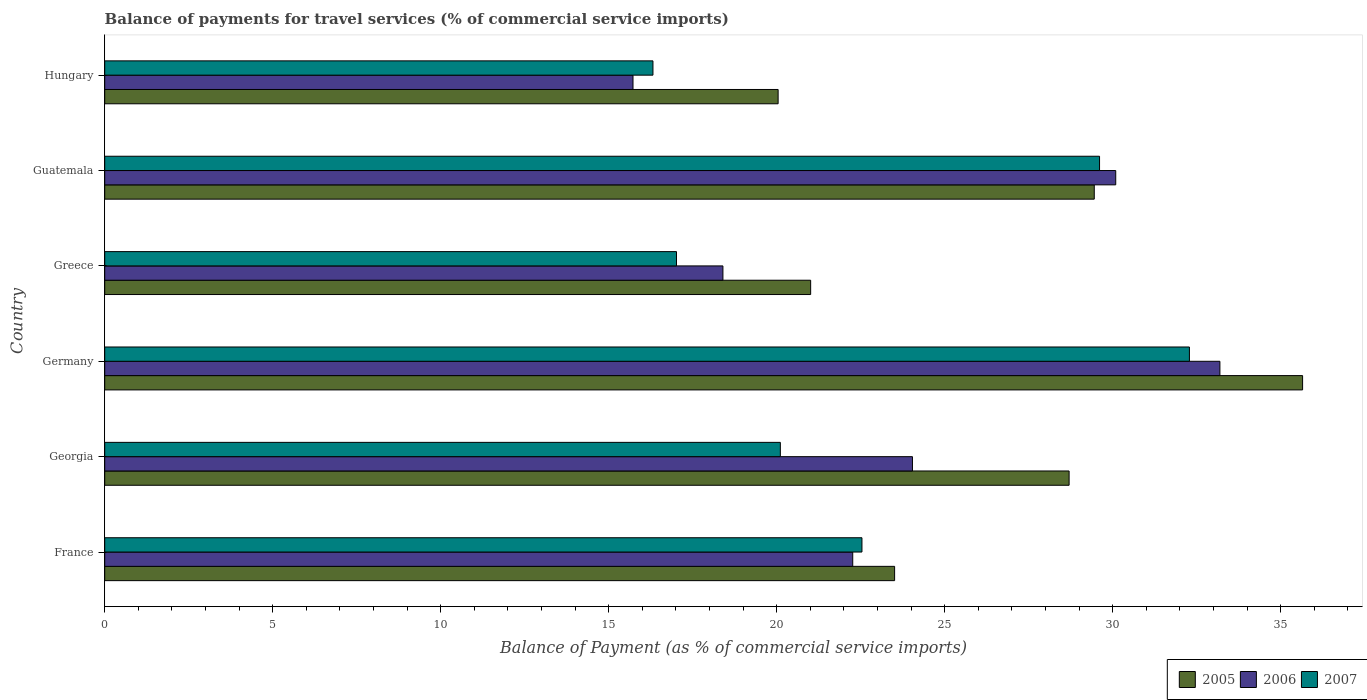How many different coloured bars are there?
Your answer should be very brief. 3. In how many cases, is the number of bars for a given country not equal to the number of legend labels?
Your response must be concise. 0. What is the balance of payments for travel services in 2005 in Germany?
Give a very brief answer. 35.65. Across all countries, what is the maximum balance of payments for travel services in 2007?
Your answer should be very brief. 32.28. Across all countries, what is the minimum balance of payments for travel services in 2007?
Offer a terse response. 16.32. In which country was the balance of payments for travel services in 2005 maximum?
Make the answer very short. Germany. In which country was the balance of payments for travel services in 2006 minimum?
Ensure brevity in your answer.  Hungary. What is the total balance of payments for travel services in 2006 in the graph?
Offer a terse response. 143.71. What is the difference between the balance of payments for travel services in 2005 in Georgia and that in Guatemala?
Keep it short and to the point. -0.75. What is the difference between the balance of payments for travel services in 2005 in Guatemala and the balance of payments for travel services in 2006 in Hungary?
Offer a terse response. 13.73. What is the average balance of payments for travel services in 2006 per country?
Make the answer very short. 23.95. What is the difference between the balance of payments for travel services in 2005 and balance of payments for travel services in 2006 in Germany?
Provide a succinct answer. 2.46. In how many countries, is the balance of payments for travel services in 2006 greater than 2 %?
Provide a succinct answer. 6. What is the ratio of the balance of payments for travel services in 2005 in France to that in Georgia?
Your answer should be compact. 0.82. Is the balance of payments for travel services in 2006 in France less than that in Hungary?
Your answer should be very brief. No. Is the difference between the balance of payments for travel services in 2005 in Greece and Hungary greater than the difference between the balance of payments for travel services in 2006 in Greece and Hungary?
Ensure brevity in your answer.  No. What is the difference between the highest and the second highest balance of payments for travel services in 2007?
Provide a short and direct response. 2.67. What is the difference between the highest and the lowest balance of payments for travel services in 2007?
Offer a very short reply. 15.97. Is the sum of the balance of payments for travel services in 2006 in France and Greece greater than the maximum balance of payments for travel services in 2005 across all countries?
Make the answer very short. Yes. What does the 2nd bar from the top in Georgia represents?
Your answer should be compact. 2006. What does the 2nd bar from the bottom in Georgia represents?
Your answer should be very brief. 2006. Is it the case that in every country, the sum of the balance of payments for travel services in 2007 and balance of payments for travel services in 2006 is greater than the balance of payments for travel services in 2005?
Make the answer very short. Yes. Are all the bars in the graph horizontal?
Provide a short and direct response. Yes. What is the difference between two consecutive major ticks on the X-axis?
Provide a succinct answer. 5. Does the graph contain any zero values?
Your response must be concise. No. Where does the legend appear in the graph?
Keep it short and to the point. Bottom right. How many legend labels are there?
Offer a very short reply. 3. How are the legend labels stacked?
Provide a short and direct response. Horizontal. What is the title of the graph?
Offer a terse response. Balance of payments for travel services (% of commercial service imports). Does "2013" appear as one of the legend labels in the graph?
Offer a terse response. No. What is the label or title of the X-axis?
Provide a short and direct response. Balance of Payment (as % of commercial service imports). What is the label or title of the Y-axis?
Offer a terse response. Country. What is the Balance of Payment (as % of commercial service imports) in 2005 in France?
Ensure brevity in your answer.  23.51. What is the Balance of Payment (as % of commercial service imports) in 2006 in France?
Your answer should be very brief. 22.26. What is the Balance of Payment (as % of commercial service imports) of 2007 in France?
Offer a terse response. 22.54. What is the Balance of Payment (as % of commercial service imports) of 2005 in Georgia?
Make the answer very short. 28.7. What is the Balance of Payment (as % of commercial service imports) in 2006 in Georgia?
Provide a short and direct response. 24.04. What is the Balance of Payment (as % of commercial service imports) of 2007 in Georgia?
Offer a very short reply. 20.11. What is the Balance of Payment (as % of commercial service imports) in 2005 in Germany?
Keep it short and to the point. 35.65. What is the Balance of Payment (as % of commercial service imports) in 2006 in Germany?
Offer a very short reply. 33.19. What is the Balance of Payment (as % of commercial service imports) in 2007 in Germany?
Your answer should be very brief. 32.28. What is the Balance of Payment (as % of commercial service imports) of 2005 in Greece?
Your answer should be very brief. 21.01. What is the Balance of Payment (as % of commercial service imports) in 2006 in Greece?
Give a very brief answer. 18.4. What is the Balance of Payment (as % of commercial service imports) of 2007 in Greece?
Your answer should be compact. 17.02. What is the Balance of Payment (as % of commercial service imports) of 2005 in Guatemala?
Your answer should be compact. 29.45. What is the Balance of Payment (as % of commercial service imports) of 2006 in Guatemala?
Make the answer very short. 30.09. What is the Balance of Payment (as % of commercial service imports) of 2007 in Guatemala?
Ensure brevity in your answer.  29.61. What is the Balance of Payment (as % of commercial service imports) of 2005 in Hungary?
Make the answer very short. 20.04. What is the Balance of Payment (as % of commercial service imports) of 2006 in Hungary?
Ensure brevity in your answer.  15.72. What is the Balance of Payment (as % of commercial service imports) in 2007 in Hungary?
Keep it short and to the point. 16.32. Across all countries, what is the maximum Balance of Payment (as % of commercial service imports) in 2005?
Keep it short and to the point. 35.65. Across all countries, what is the maximum Balance of Payment (as % of commercial service imports) of 2006?
Give a very brief answer. 33.19. Across all countries, what is the maximum Balance of Payment (as % of commercial service imports) in 2007?
Your answer should be compact. 32.28. Across all countries, what is the minimum Balance of Payment (as % of commercial service imports) in 2005?
Provide a short and direct response. 20.04. Across all countries, what is the minimum Balance of Payment (as % of commercial service imports) of 2006?
Give a very brief answer. 15.72. Across all countries, what is the minimum Balance of Payment (as % of commercial service imports) in 2007?
Your answer should be compact. 16.32. What is the total Balance of Payment (as % of commercial service imports) of 2005 in the graph?
Make the answer very short. 158.37. What is the total Balance of Payment (as % of commercial service imports) in 2006 in the graph?
Ensure brevity in your answer.  143.71. What is the total Balance of Payment (as % of commercial service imports) of 2007 in the graph?
Offer a very short reply. 137.87. What is the difference between the Balance of Payment (as % of commercial service imports) of 2005 in France and that in Georgia?
Offer a terse response. -5.19. What is the difference between the Balance of Payment (as % of commercial service imports) of 2006 in France and that in Georgia?
Give a very brief answer. -1.78. What is the difference between the Balance of Payment (as % of commercial service imports) of 2007 in France and that in Georgia?
Give a very brief answer. 2.43. What is the difference between the Balance of Payment (as % of commercial service imports) in 2005 in France and that in Germany?
Keep it short and to the point. -12.14. What is the difference between the Balance of Payment (as % of commercial service imports) in 2006 in France and that in Germany?
Your response must be concise. -10.93. What is the difference between the Balance of Payment (as % of commercial service imports) of 2007 in France and that in Germany?
Give a very brief answer. -9.75. What is the difference between the Balance of Payment (as % of commercial service imports) of 2005 in France and that in Greece?
Ensure brevity in your answer.  2.5. What is the difference between the Balance of Payment (as % of commercial service imports) of 2006 in France and that in Greece?
Your answer should be very brief. 3.86. What is the difference between the Balance of Payment (as % of commercial service imports) in 2007 in France and that in Greece?
Offer a terse response. 5.52. What is the difference between the Balance of Payment (as % of commercial service imports) of 2005 in France and that in Guatemala?
Provide a succinct answer. -5.94. What is the difference between the Balance of Payment (as % of commercial service imports) in 2006 in France and that in Guatemala?
Provide a short and direct response. -7.83. What is the difference between the Balance of Payment (as % of commercial service imports) of 2007 in France and that in Guatemala?
Make the answer very short. -7.07. What is the difference between the Balance of Payment (as % of commercial service imports) in 2005 in France and that in Hungary?
Your answer should be compact. 3.47. What is the difference between the Balance of Payment (as % of commercial service imports) in 2006 in France and that in Hungary?
Give a very brief answer. 6.54. What is the difference between the Balance of Payment (as % of commercial service imports) in 2007 in France and that in Hungary?
Your response must be concise. 6.22. What is the difference between the Balance of Payment (as % of commercial service imports) of 2005 in Georgia and that in Germany?
Ensure brevity in your answer.  -6.95. What is the difference between the Balance of Payment (as % of commercial service imports) in 2006 in Georgia and that in Germany?
Give a very brief answer. -9.15. What is the difference between the Balance of Payment (as % of commercial service imports) in 2007 in Georgia and that in Germany?
Offer a terse response. -12.18. What is the difference between the Balance of Payment (as % of commercial service imports) in 2005 in Georgia and that in Greece?
Your response must be concise. 7.69. What is the difference between the Balance of Payment (as % of commercial service imports) of 2006 in Georgia and that in Greece?
Offer a very short reply. 5.64. What is the difference between the Balance of Payment (as % of commercial service imports) of 2007 in Georgia and that in Greece?
Give a very brief answer. 3.09. What is the difference between the Balance of Payment (as % of commercial service imports) in 2005 in Georgia and that in Guatemala?
Provide a succinct answer. -0.75. What is the difference between the Balance of Payment (as % of commercial service imports) in 2006 in Georgia and that in Guatemala?
Your answer should be very brief. -6.05. What is the difference between the Balance of Payment (as % of commercial service imports) in 2007 in Georgia and that in Guatemala?
Give a very brief answer. -9.5. What is the difference between the Balance of Payment (as % of commercial service imports) of 2005 in Georgia and that in Hungary?
Make the answer very short. 8.66. What is the difference between the Balance of Payment (as % of commercial service imports) of 2006 in Georgia and that in Hungary?
Offer a very short reply. 8.32. What is the difference between the Balance of Payment (as % of commercial service imports) of 2007 in Georgia and that in Hungary?
Offer a terse response. 3.79. What is the difference between the Balance of Payment (as % of commercial service imports) of 2005 in Germany and that in Greece?
Your response must be concise. 14.64. What is the difference between the Balance of Payment (as % of commercial service imports) of 2006 in Germany and that in Greece?
Your response must be concise. 14.79. What is the difference between the Balance of Payment (as % of commercial service imports) in 2007 in Germany and that in Greece?
Your answer should be very brief. 15.27. What is the difference between the Balance of Payment (as % of commercial service imports) in 2005 in Germany and that in Guatemala?
Your answer should be very brief. 6.2. What is the difference between the Balance of Payment (as % of commercial service imports) of 2006 in Germany and that in Guatemala?
Offer a very short reply. 3.1. What is the difference between the Balance of Payment (as % of commercial service imports) in 2007 in Germany and that in Guatemala?
Your answer should be compact. 2.67. What is the difference between the Balance of Payment (as % of commercial service imports) of 2005 in Germany and that in Hungary?
Provide a short and direct response. 15.61. What is the difference between the Balance of Payment (as % of commercial service imports) of 2006 in Germany and that in Hungary?
Keep it short and to the point. 17.47. What is the difference between the Balance of Payment (as % of commercial service imports) of 2007 in Germany and that in Hungary?
Make the answer very short. 15.97. What is the difference between the Balance of Payment (as % of commercial service imports) in 2005 in Greece and that in Guatemala?
Your answer should be compact. -8.44. What is the difference between the Balance of Payment (as % of commercial service imports) in 2006 in Greece and that in Guatemala?
Offer a terse response. -11.69. What is the difference between the Balance of Payment (as % of commercial service imports) in 2007 in Greece and that in Guatemala?
Provide a short and direct response. -12.59. What is the difference between the Balance of Payment (as % of commercial service imports) in 2005 in Greece and that in Hungary?
Make the answer very short. 0.97. What is the difference between the Balance of Payment (as % of commercial service imports) of 2006 in Greece and that in Hungary?
Ensure brevity in your answer.  2.68. What is the difference between the Balance of Payment (as % of commercial service imports) in 2007 in Greece and that in Hungary?
Provide a short and direct response. 0.7. What is the difference between the Balance of Payment (as % of commercial service imports) of 2005 in Guatemala and that in Hungary?
Your response must be concise. 9.41. What is the difference between the Balance of Payment (as % of commercial service imports) in 2006 in Guatemala and that in Hungary?
Provide a succinct answer. 14.37. What is the difference between the Balance of Payment (as % of commercial service imports) in 2007 in Guatemala and that in Hungary?
Provide a succinct answer. 13.29. What is the difference between the Balance of Payment (as % of commercial service imports) of 2005 in France and the Balance of Payment (as % of commercial service imports) of 2006 in Georgia?
Ensure brevity in your answer.  -0.53. What is the difference between the Balance of Payment (as % of commercial service imports) of 2005 in France and the Balance of Payment (as % of commercial service imports) of 2007 in Georgia?
Provide a succinct answer. 3.4. What is the difference between the Balance of Payment (as % of commercial service imports) of 2006 in France and the Balance of Payment (as % of commercial service imports) of 2007 in Georgia?
Offer a very short reply. 2.15. What is the difference between the Balance of Payment (as % of commercial service imports) of 2005 in France and the Balance of Payment (as % of commercial service imports) of 2006 in Germany?
Your answer should be compact. -9.68. What is the difference between the Balance of Payment (as % of commercial service imports) in 2005 in France and the Balance of Payment (as % of commercial service imports) in 2007 in Germany?
Give a very brief answer. -8.77. What is the difference between the Balance of Payment (as % of commercial service imports) in 2006 in France and the Balance of Payment (as % of commercial service imports) in 2007 in Germany?
Give a very brief answer. -10.02. What is the difference between the Balance of Payment (as % of commercial service imports) in 2005 in France and the Balance of Payment (as % of commercial service imports) in 2006 in Greece?
Offer a very short reply. 5.11. What is the difference between the Balance of Payment (as % of commercial service imports) of 2005 in France and the Balance of Payment (as % of commercial service imports) of 2007 in Greece?
Give a very brief answer. 6.49. What is the difference between the Balance of Payment (as % of commercial service imports) of 2006 in France and the Balance of Payment (as % of commercial service imports) of 2007 in Greece?
Your answer should be compact. 5.25. What is the difference between the Balance of Payment (as % of commercial service imports) in 2005 in France and the Balance of Payment (as % of commercial service imports) in 2006 in Guatemala?
Offer a terse response. -6.58. What is the difference between the Balance of Payment (as % of commercial service imports) of 2005 in France and the Balance of Payment (as % of commercial service imports) of 2007 in Guatemala?
Ensure brevity in your answer.  -6.1. What is the difference between the Balance of Payment (as % of commercial service imports) in 2006 in France and the Balance of Payment (as % of commercial service imports) in 2007 in Guatemala?
Give a very brief answer. -7.35. What is the difference between the Balance of Payment (as % of commercial service imports) of 2005 in France and the Balance of Payment (as % of commercial service imports) of 2006 in Hungary?
Provide a succinct answer. 7.79. What is the difference between the Balance of Payment (as % of commercial service imports) of 2005 in France and the Balance of Payment (as % of commercial service imports) of 2007 in Hungary?
Offer a very short reply. 7.19. What is the difference between the Balance of Payment (as % of commercial service imports) in 2006 in France and the Balance of Payment (as % of commercial service imports) in 2007 in Hungary?
Keep it short and to the point. 5.95. What is the difference between the Balance of Payment (as % of commercial service imports) in 2005 in Georgia and the Balance of Payment (as % of commercial service imports) in 2006 in Germany?
Keep it short and to the point. -4.49. What is the difference between the Balance of Payment (as % of commercial service imports) of 2005 in Georgia and the Balance of Payment (as % of commercial service imports) of 2007 in Germany?
Ensure brevity in your answer.  -3.58. What is the difference between the Balance of Payment (as % of commercial service imports) in 2006 in Georgia and the Balance of Payment (as % of commercial service imports) in 2007 in Germany?
Your answer should be very brief. -8.24. What is the difference between the Balance of Payment (as % of commercial service imports) in 2005 in Georgia and the Balance of Payment (as % of commercial service imports) in 2006 in Greece?
Keep it short and to the point. 10.3. What is the difference between the Balance of Payment (as % of commercial service imports) of 2005 in Georgia and the Balance of Payment (as % of commercial service imports) of 2007 in Greece?
Provide a short and direct response. 11.69. What is the difference between the Balance of Payment (as % of commercial service imports) in 2006 in Georgia and the Balance of Payment (as % of commercial service imports) in 2007 in Greece?
Your answer should be very brief. 7.02. What is the difference between the Balance of Payment (as % of commercial service imports) of 2005 in Georgia and the Balance of Payment (as % of commercial service imports) of 2006 in Guatemala?
Keep it short and to the point. -1.39. What is the difference between the Balance of Payment (as % of commercial service imports) in 2005 in Georgia and the Balance of Payment (as % of commercial service imports) in 2007 in Guatemala?
Your answer should be very brief. -0.91. What is the difference between the Balance of Payment (as % of commercial service imports) in 2006 in Georgia and the Balance of Payment (as % of commercial service imports) in 2007 in Guatemala?
Keep it short and to the point. -5.57. What is the difference between the Balance of Payment (as % of commercial service imports) in 2005 in Georgia and the Balance of Payment (as % of commercial service imports) in 2006 in Hungary?
Offer a terse response. 12.98. What is the difference between the Balance of Payment (as % of commercial service imports) of 2005 in Georgia and the Balance of Payment (as % of commercial service imports) of 2007 in Hungary?
Keep it short and to the point. 12.39. What is the difference between the Balance of Payment (as % of commercial service imports) of 2006 in Georgia and the Balance of Payment (as % of commercial service imports) of 2007 in Hungary?
Give a very brief answer. 7.72. What is the difference between the Balance of Payment (as % of commercial service imports) in 2005 in Germany and the Balance of Payment (as % of commercial service imports) in 2006 in Greece?
Your answer should be compact. 17.25. What is the difference between the Balance of Payment (as % of commercial service imports) in 2005 in Germany and the Balance of Payment (as % of commercial service imports) in 2007 in Greece?
Your answer should be compact. 18.63. What is the difference between the Balance of Payment (as % of commercial service imports) of 2006 in Germany and the Balance of Payment (as % of commercial service imports) of 2007 in Greece?
Offer a very short reply. 16.17. What is the difference between the Balance of Payment (as % of commercial service imports) in 2005 in Germany and the Balance of Payment (as % of commercial service imports) in 2006 in Guatemala?
Your answer should be very brief. 5.56. What is the difference between the Balance of Payment (as % of commercial service imports) in 2005 in Germany and the Balance of Payment (as % of commercial service imports) in 2007 in Guatemala?
Your answer should be very brief. 6.04. What is the difference between the Balance of Payment (as % of commercial service imports) in 2006 in Germany and the Balance of Payment (as % of commercial service imports) in 2007 in Guatemala?
Provide a succinct answer. 3.58. What is the difference between the Balance of Payment (as % of commercial service imports) in 2005 in Germany and the Balance of Payment (as % of commercial service imports) in 2006 in Hungary?
Make the answer very short. 19.93. What is the difference between the Balance of Payment (as % of commercial service imports) of 2005 in Germany and the Balance of Payment (as % of commercial service imports) of 2007 in Hungary?
Your response must be concise. 19.34. What is the difference between the Balance of Payment (as % of commercial service imports) in 2006 in Germany and the Balance of Payment (as % of commercial service imports) in 2007 in Hungary?
Offer a terse response. 16.87. What is the difference between the Balance of Payment (as % of commercial service imports) in 2005 in Greece and the Balance of Payment (as % of commercial service imports) in 2006 in Guatemala?
Your answer should be very brief. -9.08. What is the difference between the Balance of Payment (as % of commercial service imports) in 2005 in Greece and the Balance of Payment (as % of commercial service imports) in 2007 in Guatemala?
Ensure brevity in your answer.  -8.6. What is the difference between the Balance of Payment (as % of commercial service imports) of 2006 in Greece and the Balance of Payment (as % of commercial service imports) of 2007 in Guatemala?
Keep it short and to the point. -11.21. What is the difference between the Balance of Payment (as % of commercial service imports) of 2005 in Greece and the Balance of Payment (as % of commercial service imports) of 2006 in Hungary?
Offer a terse response. 5.29. What is the difference between the Balance of Payment (as % of commercial service imports) in 2005 in Greece and the Balance of Payment (as % of commercial service imports) in 2007 in Hungary?
Provide a succinct answer. 4.69. What is the difference between the Balance of Payment (as % of commercial service imports) in 2006 in Greece and the Balance of Payment (as % of commercial service imports) in 2007 in Hungary?
Your answer should be very brief. 2.08. What is the difference between the Balance of Payment (as % of commercial service imports) of 2005 in Guatemala and the Balance of Payment (as % of commercial service imports) of 2006 in Hungary?
Provide a succinct answer. 13.73. What is the difference between the Balance of Payment (as % of commercial service imports) of 2005 in Guatemala and the Balance of Payment (as % of commercial service imports) of 2007 in Hungary?
Give a very brief answer. 13.13. What is the difference between the Balance of Payment (as % of commercial service imports) in 2006 in Guatemala and the Balance of Payment (as % of commercial service imports) in 2007 in Hungary?
Your answer should be compact. 13.77. What is the average Balance of Payment (as % of commercial service imports) of 2005 per country?
Give a very brief answer. 26.39. What is the average Balance of Payment (as % of commercial service imports) in 2006 per country?
Your answer should be compact. 23.95. What is the average Balance of Payment (as % of commercial service imports) in 2007 per country?
Give a very brief answer. 22.98. What is the difference between the Balance of Payment (as % of commercial service imports) of 2005 and Balance of Payment (as % of commercial service imports) of 2006 in France?
Ensure brevity in your answer.  1.25. What is the difference between the Balance of Payment (as % of commercial service imports) in 2005 and Balance of Payment (as % of commercial service imports) in 2007 in France?
Your answer should be compact. 0.97. What is the difference between the Balance of Payment (as % of commercial service imports) of 2006 and Balance of Payment (as % of commercial service imports) of 2007 in France?
Provide a short and direct response. -0.27. What is the difference between the Balance of Payment (as % of commercial service imports) in 2005 and Balance of Payment (as % of commercial service imports) in 2006 in Georgia?
Keep it short and to the point. 4.66. What is the difference between the Balance of Payment (as % of commercial service imports) of 2005 and Balance of Payment (as % of commercial service imports) of 2007 in Georgia?
Offer a very short reply. 8.59. What is the difference between the Balance of Payment (as % of commercial service imports) of 2006 and Balance of Payment (as % of commercial service imports) of 2007 in Georgia?
Give a very brief answer. 3.93. What is the difference between the Balance of Payment (as % of commercial service imports) in 2005 and Balance of Payment (as % of commercial service imports) in 2006 in Germany?
Your response must be concise. 2.46. What is the difference between the Balance of Payment (as % of commercial service imports) in 2005 and Balance of Payment (as % of commercial service imports) in 2007 in Germany?
Keep it short and to the point. 3.37. What is the difference between the Balance of Payment (as % of commercial service imports) of 2006 and Balance of Payment (as % of commercial service imports) of 2007 in Germany?
Your response must be concise. 0.91. What is the difference between the Balance of Payment (as % of commercial service imports) of 2005 and Balance of Payment (as % of commercial service imports) of 2006 in Greece?
Provide a short and direct response. 2.61. What is the difference between the Balance of Payment (as % of commercial service imports) in 2005 and Balance of Payment (as % of commercial service imports) in 2007 in Greece?
Provide a short and direct response. 3.99. What is the difference between the Balance of Payment (as % of commercial service imports) in 2006 and Balance of Payment (as % of commercial service imports) in 2007 in Greece?
Ensure brevity in your answer.  1.38. What is the difference between the Balance of Payment (as % of commercial service imports) of 2005 and Balance of Payment (as % of commercial service imports) of 2006 in Guatemala?
Offer a terse response. -0.64. What is the difference between the Balance of Payment (as % of commercial service imports) of 2005 and Balance of Payment (as % of commercial service imports) of 2007 in Guatemala?
Ensure brevity in your answer.  -0.16. What is the difference between the Balance of Payment (as % of commercial service imports) in 2006 and Balance of Payment (as % of commercial service imports) in 2007 in Guatemala?
Provide a succinct answer. 0.48. What is the difference between the Balance of Payment (as % of commercial service imports) of 2005 and Balance of Payment (as % of commercial service imports) of 2006 in Hungary?
Offer a terse response. 4.32. What is the difference between the Balance of Payment (as % of commercial service imports) in 2005 and Balance of Payment (as % of commercial service imports) in 2007 in Hungary?
Provide a succinct answer. 3.73. What is the difference between the Balance of Payment (as % of commercial service imports) of 2006 and Balance of Payment (as % of commercial service imports) of 2007 in Hungary?
Give a very brief answer. -0.59. What is the ratio of the Balance of Payment (as % of commercial service imports) of 2005 in France to that in Georgia?
Your response must be concise. 0.82. What is the ratio of the Balance of Payment (as % of commercial service imports) in 2006 in France to that in Georgia?
Offer a very short reply. 0.93. What is the ratio of the Balance of Payment (as % of commercial service imports) of 2007 in France to that in Georgia?
Your answer should be compact. 1.12. What is the ratio of the Balance of Payment (as % of commercial service imports) in 2005 in France to that in Germany?
Provide a short and direct response. 0.66. What is the ratio of the Balance of Payment (as % of commercial service imports) of 2006 in France to that in Germany?
Provide a short and direct response. 0.67. What is the ratio of the Balance of Payment (as % of commercial service imports) in 2007 in France to that in Germany?
Make the answer very short. 0.7. What is the ratio of the Balance of Payment (as % of commercial service imports) in 2005 in France to that in Greece?
Ensure brevity in your answer.  1.12. What is the ratio of the Balance of Payment (as % of commercial service imports) in 2006 in France to that in Greece?
Your answer should be very brief. 1.21. What is the ratio of the Balance of Payment (as % of commercial service imports) of 2007 in France to that in Greece?
Make the answer very short. 1.32. What is the ratio of the Balance of Payment (as % of commercial service imports) of 2005 in France to that in Guatemala?
Make the answer very short. 0.8. What is the ratio of the Balance of Payment (as % of commercial service imports) in 2006 in France to that in Guatemala?
Ensure brevity in your answer.  0.74. What is the ratio of the Balance of Payment (as % of commercial service imports) in 2007 in France to that in Guatemala?
Ensure brevity in your answer.  0.76. What is the ratio of the Balance of Payment (as % of commercial service imports) of 2005 in France to that in Hungary?
Offer a very short reply. 1.17. What is the ratio of the Balance of Payment (as % of commercial service imports) of 2006 in France to that in Hungary?
Offer a very short reply. 1.42. What is the ratio of the Balance of Payment (as % of commercial service imports) in 2007 in France to that in Hungary?
Give a very brief answer. 1.38. What is the ratio of the Balance of Payment (as % of commercial service imports) in 2005 in Georgia to that in Germany?
Give a very brief answer. 0.81. What is the ratio of the Balance of Payment (as % of commercial service imports) in 2006 in Georgia to that in Germany?
Offer a very short reply. 0.72. What is the ratio of the Balance of Payment (as % of commercial service imports) of 2007 in Georgia to that in Germany?
Your answer should be very brief. 0.62. What is the ratio of the Balance of Payment (as % of commercial service imports) of 2005 in Georgia to that in Greece?
Your answer should be compact. 1.37. What is the ratio of the Balance of Payment (as % of commercial service imports) in 2006 in Georgia to that in Greece?
Your answer should be very brief. 1.31. What is the ratio of the Balance of Payment (as % of commercial service imports) in 2007 in Georgia to that in Greece?
Make the answer very short. 1.18. What is the ratio of the Balance of Payment (as % of commercial service imports) in 2005 in Georgia to that in Guatemala?
Offer a terse response. 0.97. What is the ratio of the Balance of Payment (as % of commercial service imports) in 2006 in Georgia to that in Guatemala?
Provide a succinct answer. 0.8. What is the ratio of the Balance of Payment (as % of commercial service imports) of 2007 in Georgia to that in Guatemala?
Offer a very short reply. 0.68. What is the ratio of the Balance of Payment (as % of commercial service imports) in 2005 in Georgia to that in Hungary?
Your answer should be very brief. 1.43. What is the ratio of the Balance of Payment (as % of commercial service imports) in 2006 in Georgia to that in Hungary?
Your answer should be compact. 1.53. What is the ratio of the Balance of Payment (as % of commercial service imports) of 2007 in Georgia to that in Hungary?
Provide a succinct answer. 1.23. What is the ratio of the Balance of Payment (as % of commercial service imports) of 2005 in Germany to that in Greece?
Your answer should be very brief. 1.7. What is the ratio of the Balance of Payment (as % of commercial service imports) in 2006 in Germany to that in Greece?
Give a very brief answer. 1.8. What is the ratio of the Balance of Payment (as % of commercial service imports) of 2007 in Germany to that in Greece?
Keep it short and to the point. 1.9. What is the ratio of the Balance of Payment (as % of commercial service imports) of 2005 in Germany to that in Guatemala?
Ensure brevity in your answer.  1.21. What is the ratio of the Balance of Payment (as % of commercial service imports) of 2006 in Germany to that in Guatemala?
Provide a succinct answer. 1.1. What is the ratio of the Balance of Payment (as % of commercial service imports) of 2007 in Germany to that in Guatemala?
Offer a very short reply. 1.09. What is the ratio of the Balance of Payment (as % of commercial service imports) of 2005 in Germany to that in Hungary?
Provide a short and direct response. 1.78. What is the ratio of the Balance of Payment (as % of commercial service imports) in 2006 in Germany to that in Hungary?
Offer a very short reply. 2.11. What is the ratio of the Balance of Payment (as % of commercial service imports) of 2007 in Germany to that in Hungary?
Provide a short and direct response. 1.98. What is the ratio of the Balance of Payment (as % of commercial service imports) of 2005 in Greece to that in Guatemala?
Your answer should be very brief. 0.71. What is the ratio of the Balance of Payment (as % of commercial service imports) of 2006 in Greece to that in Guatemala?
Provide a short and direct response. 0.61. What is the ratio of the Balance of Payment (as % of commercial service imports) in 2007 in Greece to that in Guatemala?
Ensure brevity in your answer.  0.57. What is the ratio of the Balance of Payment (as % of commercial service imports) in 2005 in Greece to that in Hungary?
Provide a short and direct response. 1.05. What is the ratio of the Balance of Payment (as % of commercial service imports) of 2006 in Greece to that in Hungary?
Your answer should be compact. 1.17. What is the ratio of the Balance of Payment (as % of commercial service imports) of 2007 in Greece to that in Hungary?
Give a very brief answer. 1.04. What is the ratio of the Balance of Payment (as % of commercial service imports) of 2005 in Guatemala to that in Hungary?
Keep it short and to the point. 1.47. What is the ratio of the Balance of Payment (as % of commercial service imports) of 2006 in Guatemala to that in Hungary?
Ensure brevity in your answer.  1.91. What is the ratio of the Balance of Payment (as % of commercial service imports) in 2007 in Guatemala to that in Hungary?
Your answer should be compact. 1.81. What is the difference between the highest and the second highest Balance of Payment (as % of commercial service imports) in 2005?
Offer a terse response. 6.2. What is the difference between the highest and the second highest Balance of Payment (as % of commercial service imports) in 2006?
Your answer should be very brief. 3.1. What is the difference between the highest and the second highest Balance of Payment (as % of commercial service imports) in 2007?
Provide a succinct answer. 2.67. What is the difference between the highest and the lowest Balance of Payment (as % of commercial service imports) of 2005?
Your answer should be compact. 15.61. What is the difference between the highest and the lowest Balance of Payment (as % of commercial service imports) of 2006?
Your answer should be very brief. 17.47. What is the difference between the highest and the lowest Balance of Payment (as % of commercial service imports) of 2007?
Give a very brief answer. 15.97. 